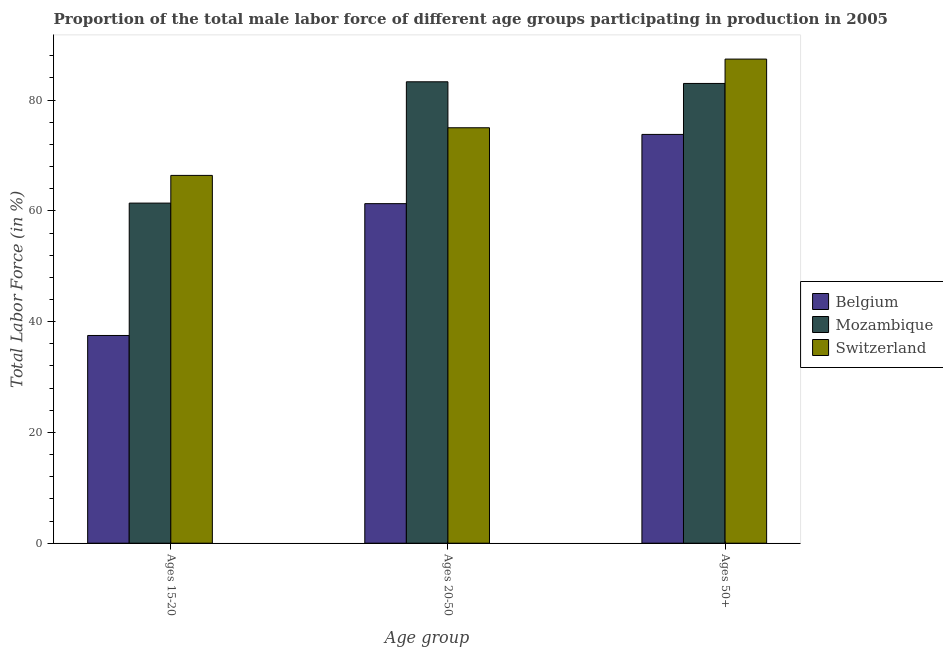How many different coloured bars are there?
Provide a succinct answer. 3. How many groups of bars are there?
Offer a very short reply. 3. How many bars are there on the 2nd tick from the right?
Offer a very short reply. 3. What is the label of the 3rd group of bars from the left?
Your answer should be very brief. Ages 50+. What is the percentage of male labor force within the age group 15-20 in Mozambique?
Give a very brief answer. 61.4. Across all countries, what is the maximum percentage of male labor force within the age group 15-20?
Your response must be concise. 66.4. Across all countries, what is the minimum percentage of male labor force within the age group 15-20?
Provide a succinct answer. 37.5. In which country was the percentage of male labor force within the age group 20-50 maximum?
Keep it short and to the point. Mozambique. In which country was the percentage of male labor force above age 50 minimum?
Your response must be concise. Belgium. What is the total percentage of male labor force within the age group 20-50 in the graph?
Make the answer very short. 219.6. What is the difference between the percentage of male labor force within the age group 20-50 in Switzerland and that in Belgium?
Your response must be concise. 13.7. What is the difference between the percentage of male labor force within the age group 15-20 in Mozambique and the percentage of male labor force above age 50 in Belgium?
Make the answer very short. -12.4. What is the average percentage of male labor force above age 50 per country?
Your response must be concise. 81.4. What is the difference between the percentage of male labor force within the age group 15-20 and percentage of male labor force above age 50 in Mozambique?
Offer a very short reply. -21.6. In how many countries, is the percentage of male labor force within the age group 20-50 greater than 44 %?
Offer a terse response. 3. What is the ratio of the percentage of male labor force above age 50 in Mozambique to that in Switzerland?
Your answer should be compact. 0.95. Is the difference between the percentage of male labor force above age 50 in Belgium and Mozambique greater than the difference between the percentage of male labor force within the age group 20-50 in Belgium and Mozambique?
Ensure brevity in your answer.  Yes. What is the difference between the highest and the second highest percentage of male labor force within the age group 15-20?
Offer a terse response. 5. What is the difference between the highest and the lowest percentage of male labor force above age 50?
Keep it short and to the point. 13.6. What does the 1st bar from the left in Ages 15-20 represents?
Provide a short and direct response. Belgium. What does the 2nd bar from the right in Ages 15-20 represents?
Your answer should be compact. Mozambique. Are all the bars in the graph horizontal?
Offer a terse response. No. Are the values on the major ticks of Y-axis written in scientific E-notation?
Your response must be concise. No. How many legend labels are there?
Make the answer very short. 3. How are the legend labels stacked?
Ensure brevity in your answer.  Vertical. What is the title of the graph?
Provide a succinct answer. Proportion of the total male labor force of different age groups participating in production in 2005. Does "Macedonia" appear as one of the legend labels in the graph?
Provide a succinct answer. No. What is the label or title of the X-axis?
Your answer should be very brief. Age group. What is the label or title of the Y-axis?
Offer a terse response. Total Labor Force (in %). What is the Total Labor Force (in %) of Belgium in Ages 15-20?
Provide a short and direct response. 37.5. What is the Total Labor Force (in %) in Mozambique in Ages 15-20?
Provide a succinct answer. 61.4. What is the Total Labor Force (in %) of Switzerland in Ages 15-20?
Give a very brief answer. 66.4. What is the Total Labor Force (in %) in Belgium in Ages 20-50?
Offer a terse response. 61.3. What is the Total Labor Force (in %) in Mozambique in Ages 20-50?
Your response must be concise. 83.3. What is the Total Labor Force (in %) of Switzerland in Ages 20-50?
Your response must be concise. 75. What is the Total Labor Force (in %) of Belgium in Ages 50+?
Your answer should be very brief. 73.8. What is the Total Labor Force (in %) in Switzerland in Ages 50+?
Your answer should be very brief. 87.4. Across all Age group, what is the maximum Total Labor Force (in %) of Belgium?
Give a very brief answer. 73.8. Across all Age group, what is the maximum Total Labor Force (in %) in Mozambique?
Give a very brief answer. 83.3. Across all Age group, what is the maximum Total Labor Force (in %) in Switzerland?
Your answer should be very brief. 87.4. Across all Age group, what is the minimum Total Labor Force (in %) of Belgium?
Provide a succinct answer. 37.5. Across all Age group, what is the minimum Total Labor Force (in %) in Mozambique?
Your answer should be compact. 61.4. Across all Age group, what is the minimum Total Labor Force (in %) in Switzerland?
Your response must be concise. 66.4. What is the total Total Labor Force (in %) of Belgium in the graph?
Offer a terse response. 172.6. What is the total Total Labor Force (in %) in Mozambique in the graph?
Offer a terse response. 227.7. What is the total Total Labor Force (in %) in Switzerland in the graph?
Give a very brief answer. 228.8. What is the difference between the Total Labor Force (in %) of Belgium in Ages 15-20 and that in Ages 20-50?
Make the answer very short. -23.8. What is the difference between the Total Labor Force (in %) of Mozambique in Ages 15-20 and that in Ages 20-50?
Make the answer very short. -21.9. What is the difference between the Total Labor Force (in %) of Switzerland in Ages 15-20 and that in Ages 20-50?
Give a very brief answer. -8.6. What is the difference between the Total Labor Force (in %) in Belgium in Ages 15-20 and that in Ages 50+?
Make the answer very short. -36.3. What is the difference between the Total Labor Force (in %) in Mozambique in Ages 15-20 and that in Ages 50+?
Your response must be concise. -21.6. What is the difference between the Total Labor Force (in %) in Switzerland in Ages 15-20 and that in Ages 50+?
Your response must be concise. -21. What is the difference between the Total Labor Force (in %) of Belgium in Ages 15-20 and the Total Labor Force (in %) of Mozambique in Ages 20-50?
Your response must be concise. -45.8. What is the difference between the Total Labor Force (in %) in Belgium in Ages 15-20 and the Total Labor Force (in %) in Switzerland in Ages 20-50?
Give a very brief answer. -37.5. What is the difference between the Total Labor Force (in %) in Belgium in Ages 15-20 and the Total Labor Force (in %) in Mozambique in Ages 50+?
Keep it short and to the point. -45.5. What is the difference between the Total Labor Force (in %) in Belgium in Ages 15-20 and the Total Labor Force (in %) in Switzerland in Ages 50+?
Keep it short and to the point. -49.9. What is the difference between the Total Labor Force (in %) of Mozambique in Ages 15-20 and the Total Labor Force (in %) of Switzerland in Ages 50+?
Your answer should be compact. -26. What is the difference between the Total Labor Force (in %) of Belgium in Ages 20-50 and the Total Labor Force (in %) of Mozambique in Ages 50+?
Your answer should be very brief. -21.7. What is the difference between the Total Labor Force (in %) in Belgium in Ages 20-50 and the Total Labor Force (in %) in Switzerland in Ages 50+?
Ensure brevity in your answer.  -26.1. What is the average Total Labor Force (in %) in Belgium per Age group?
Offer a terse response. 57.53. What is the average Total Labor Force (in %) in Mozambique per Age group?
Offer a very short reply. 75.9. What is the average Total Labor Force (in %) of Switzerland per Age group?
Offer a very short reply. 76.27. What is the difference between the Total Labor Force (in %) in Belgium and Total Labor Force (in %) in Mozambique in Ages 15-20?
Make the answer very short. -23.9. What is the difference between the Total Labor Force (in %) of Belgium and Total Labor Force (in %) of Switzerland in Ages 15-20?
Give a very brief answer. -28.9. What is the difference between the Total Labor Force (in %) in Belgium and Total Labor Force (in %) in Switzerland in Ages 20-50?
Provide a succinct answer. -13.7. What is the difference between the Total Labor Force (in %) of Mozambique and Total Labor Force (in %) of Switzerland in Ages 50+?
Offer a very short reply. -4.4. What is the ratio of the Total Labor Force (in %) of Belgium in Ages 15-20 to that in Ages 20-50?
Your answer should be compact. 0.61. What is the ratio of the Total Labor Force (in %) of Mozambique in Ages 15-20 to that in Ages 20-50?
Ensure brevity in your answer.  0.74. What is the ratio of the Total Labor Force (in %) of Switzerland in Ages 15-20 to that in Ages 20-50?
Offer a very short reply. 0.89. What is the ratio of the Total Labor Force (in %) of Belgium in Ages 15-20 to that in Ages 50+?
Your answer should be very brief. 0.51. What is the ratio of the Total Labor Force (in %) in Mozambique in Ages 15-20 to that in Ages 50+?
Make the answer very short. 0.74. What is the ratio of the Total Labor Force (in %) of Switzerland in Ages 15-20 to that in Ages 50+?
Offer a terse response. 0.76. What is the ratio of the Total Labor Force (in %) in Belgium in Ages 20-50 to that in Ages 50+?
Your answer should be very brief. 0.83. What is the ratio of the Total Labor Force (in %) of Switzerland in Ages 20-50 to that in Ages 50+?
Keep it short and to the point. 0.86. What is the difference between the highest and the second highest Total Labor Force (in %) of Belgium?
Your response must be concise. 12.5. What is the difference between the highest and the second highest Total Labor Force (in %) of Switzerland?
Offer a very short reply. 12.4. What is the difference between the highest and the lowest Total Labor Force (in %) of Belgium?
Your answer should be compact. 36.3. What is the difference between the highest and the lowest Total Labor Force (in %) of Mozambique?
Ensure brevity in your answer.  21.9. What is the difference between the highest and the lowest Total Labor Force (in %) of Switzerland?
Provide a short and direct response. 21. 